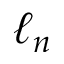<formula> <loc_0><loc_0><loc_500><loc_500>\ell _ { n }</formula> 